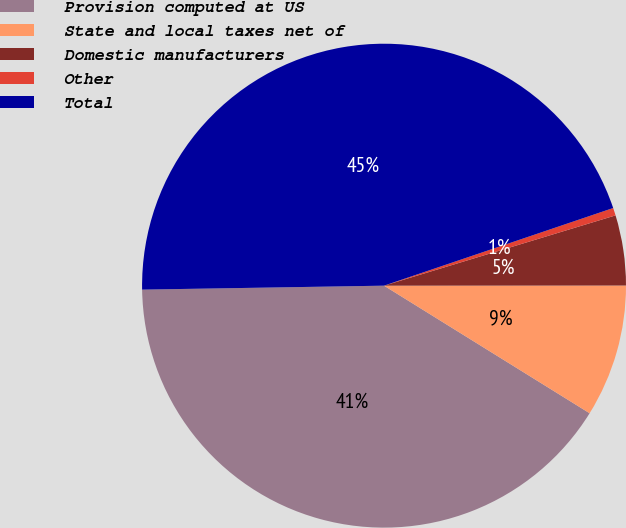Convert chart. <chart><loc_0><loc_0><loc_500><loc_500><pie_chart><fcel>Provision computed at US<fcel>State and local taxes net of<fcel>Domestic manufacturers<fcel>Other<fcel>Total<nl><fcel>40.9%<fcel>8.85%<fcel>4.68%<fcel>0.51%<fcel>45.06%<nl></chart> 